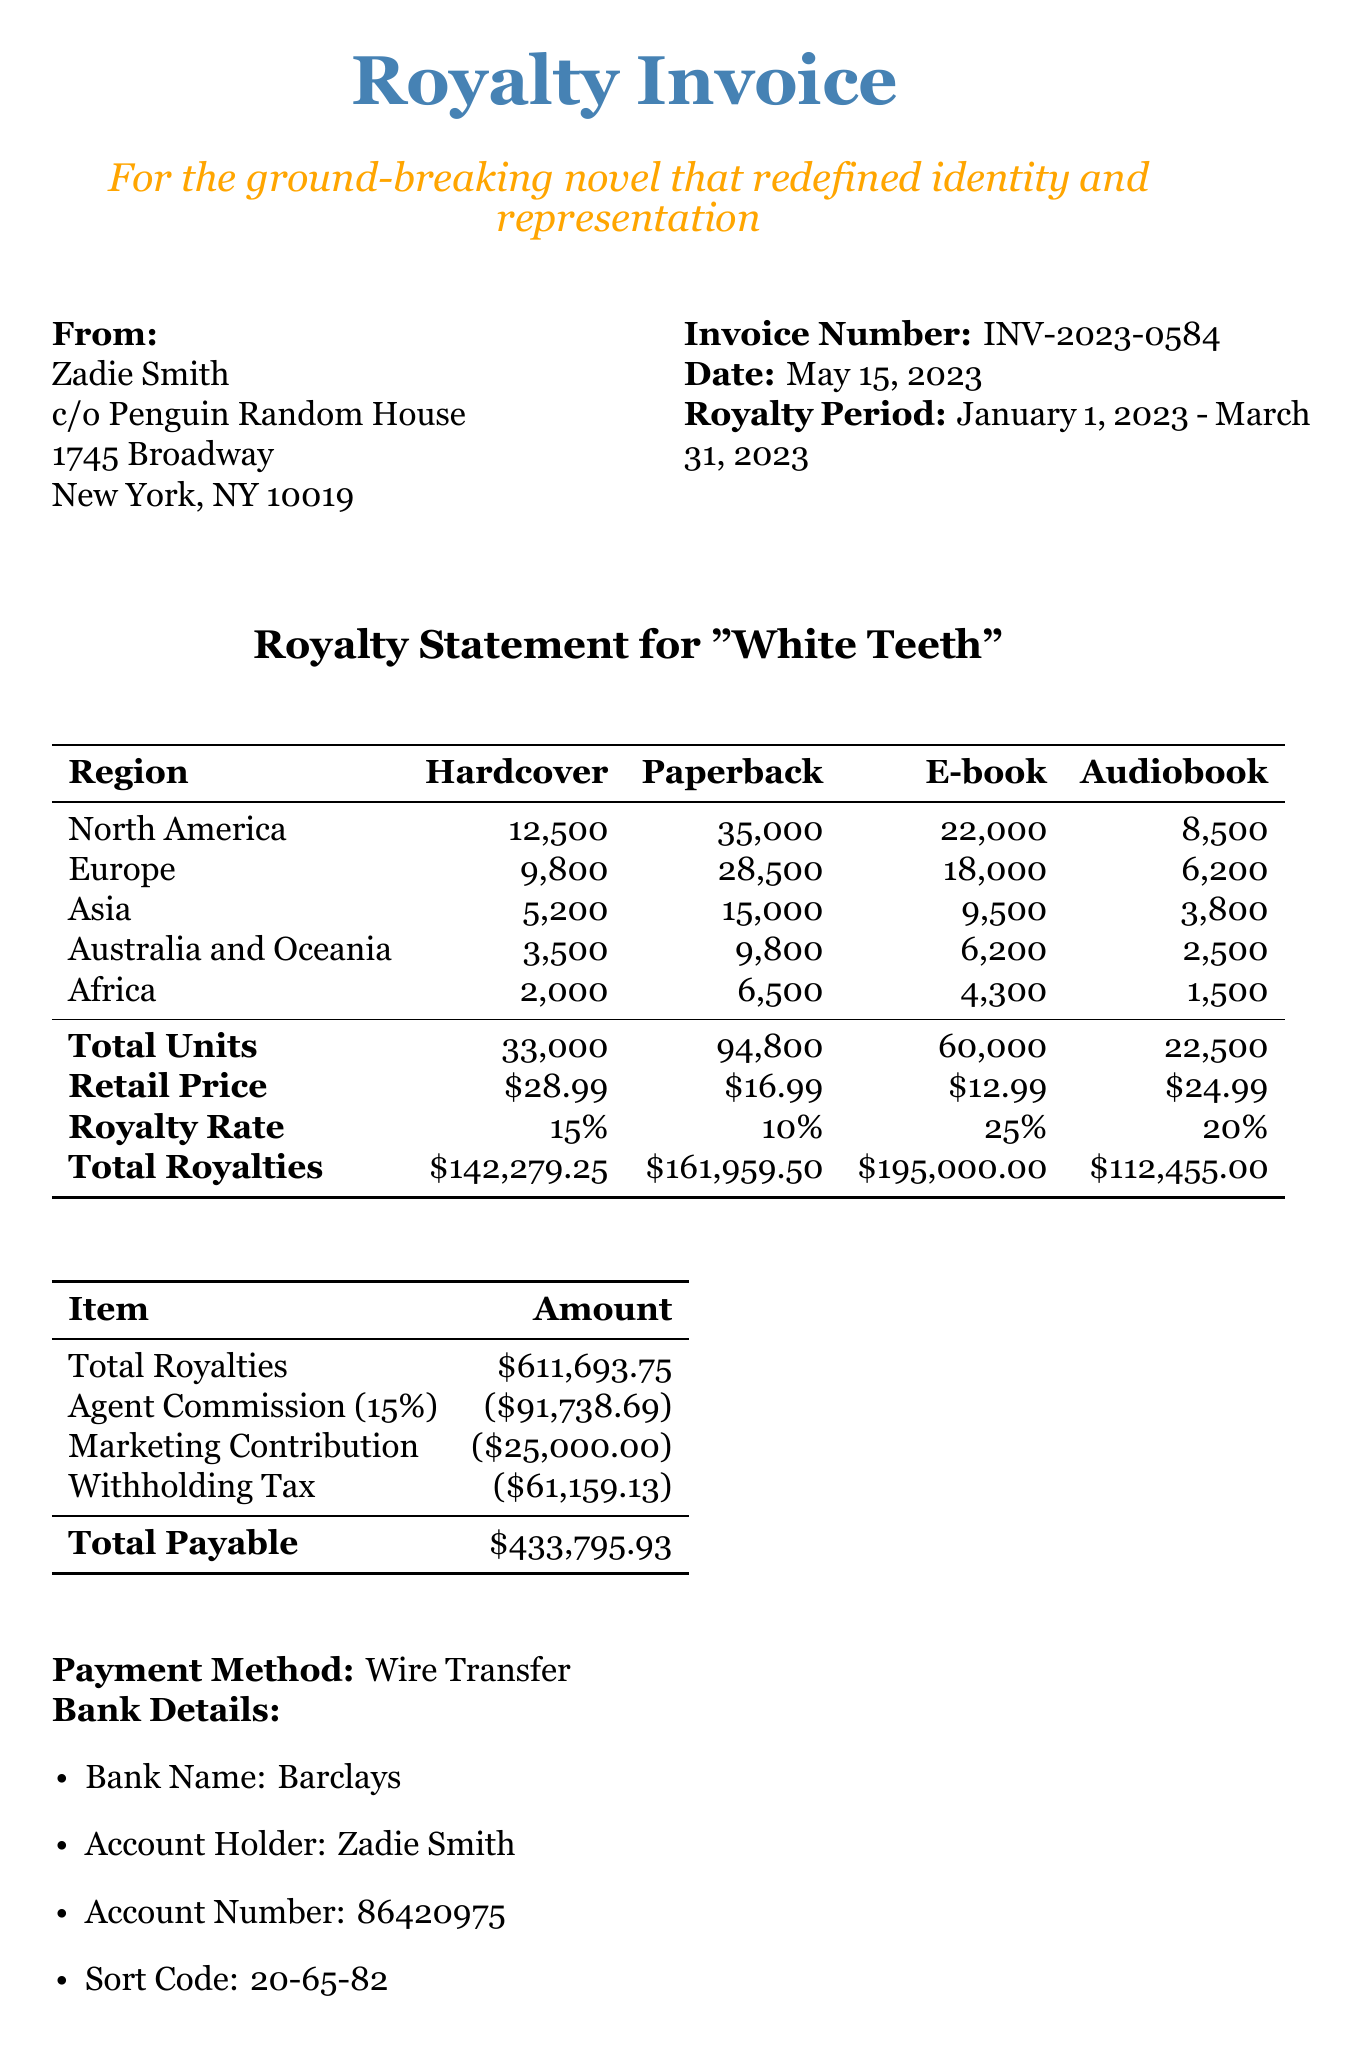What is the invoice number? The invoice number is listed at the top of the document under the invoice details.
Answer: INV-2023-0584 What is the date of the invoice? The date is mentioned alongside the invoice number in the document.
Answer: May 15, 2023 Which publisher is associated with the book? The publisher's name is provided in the sender information of the document.
Answer: Penguin Random House What is the total payable amount? This is calculated by subtracting the deductions from the total royalties, as shown in the document.
Answer: 433795.93 How many hardcover books were sold in North America? The document provides a breakdown of sales by region, specifically for hardcover books in North America.
Answer: 12500 What is the royalty rate for ebooks? The royalty rate for each format is mentioned in the royalty rate section of the document.
Answer: 25% What special note mentions a film adaptation? The special notes section includes information about a film adaptation of the book.
Answer: Film adaptation rights sold to Netflix for $2.5 million What percentage is the agent commission? The document reveals the deduction details, specifically the agent commission rate, which is expressed as a percentage.
Answer: 15% What is the name of the author? The author's name is listed at the top of the document in the sender information.
Answer: Zadie Smith 